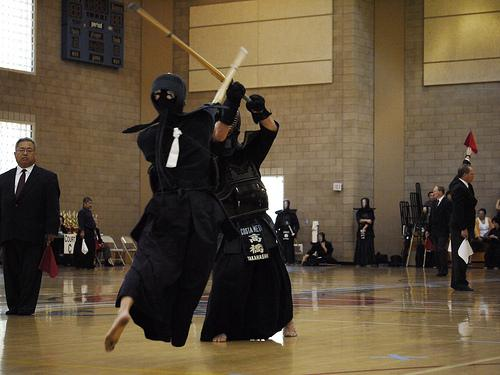Question: how the picture looks?
Choices:
A. Blurry.
B. Dark.
C. Over exposed.
D. Clear.
Answer with the letter. Answer: D Question: where did the fight going?
Choices:
A. On the wood floor.
B. On the table.
C. On the chair.
D. On the couch.
Answer with the letter. Answer: A Question: what they are doing?
Choices:
A. Fighting each other.
B. Talking.
C. Kissing.
D. Lying down.
Answer with the letter. Answer: A Question: who are in the picture?
Choices:
A. People.
B. Kids.
C. Human beings.
D. A family.
Answer with the letter. Answer: C Question: what is the dress color of fighters?
Choices:
A. Red.
B. Blue.
C. Black and white.
D. Green.
Answer with the letter. Answer: C 